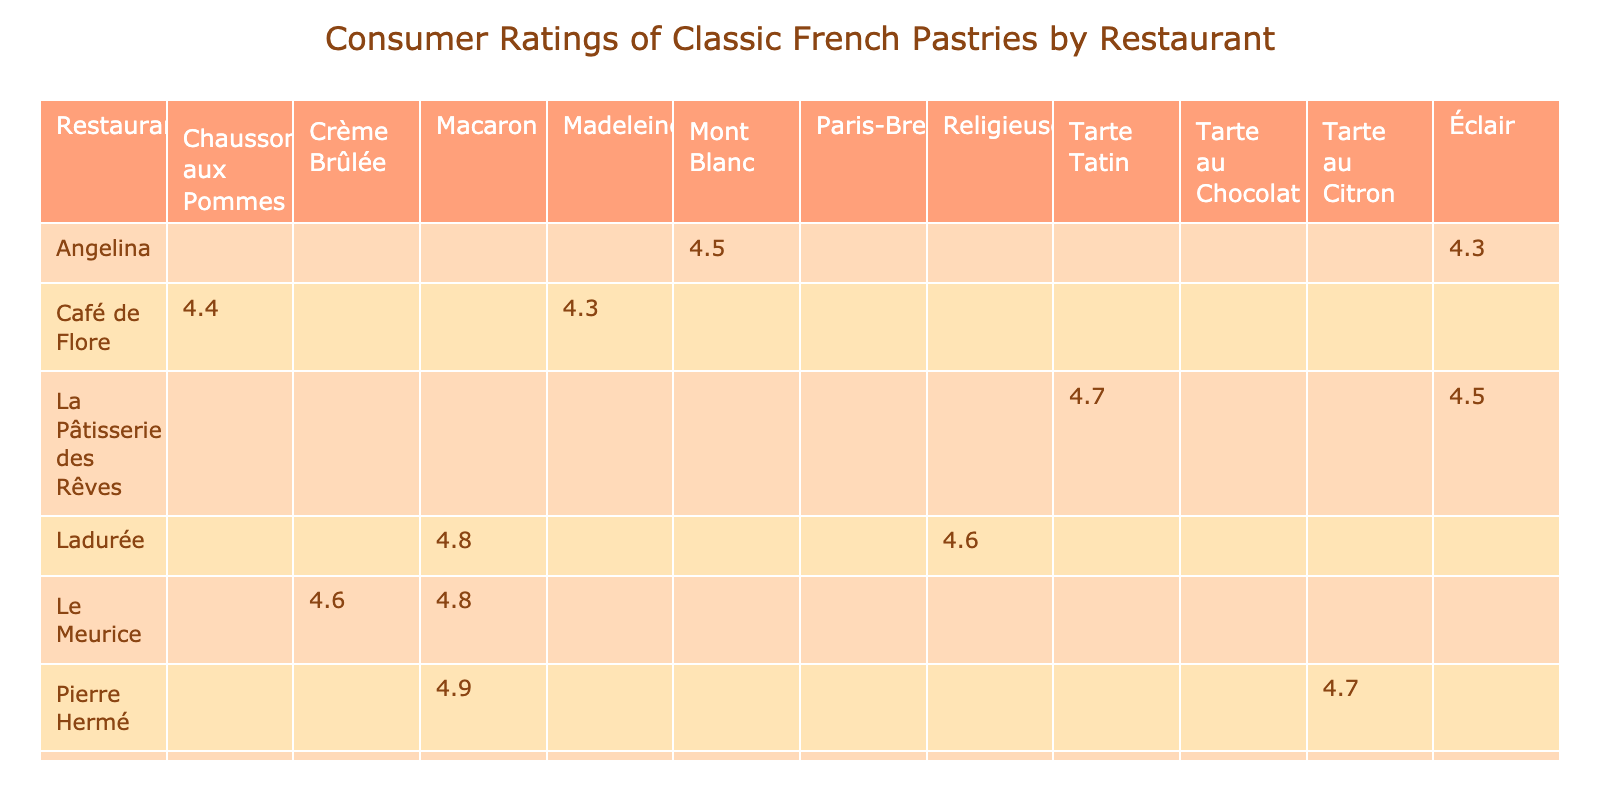What is the consumer rating of the Éclair at La Pâtisserie des Rêves? The table lists the consumer rating of the Éclair under La Pâtisserie des Rêves, which is stated as 4.5.
Answer: 4.5 Which pastry has the highest rating and at which restaurant? By examining the ratings, the Macaron at Pierre Hermé has the highest rating, listed as 4.9.
Answer: Macaron at Pierre Hermé Is the rating of the Chausson aux Pommes higher than that of the Madeleine? The rating for the Chausson aux Pommes is 4.4 and for the Madeleine is 4.3. Since 4.4 is higher than 4.3, the statement is true.
Answer: Yes What is the average consumer rating of the pastries offered by Le Meurice? The pastries from Le Meurice are rated 4.8 for the Macaron and 4.6 for the Crème Brûlée. Adding these ratings gives 4.8 + 4.6 = 9.4. Dividing by 2 gives an average of 9.4 / 2 = 4.7.
Answer: 4.7 Which restaurant has the lowest average consumer rating for its pastries? First, we summarize the ratings for each restaurant: Café de Flore has (4.4 + 4.3) / 2 = 4.35, La Pâtisserie des Rêves has (4.5 + 4.7) / 2 = 4.6, and so on. Calculating for all shows Café de Flore has the lowest average rating of 4.35.
Answer: Café de Flore Are there any restaurants serving Macarons that have a rating lower than 4.5? The table shows Ladurée has a Macaron rated at 4.8 and Pierre Hermé has one rated 4.9. Therefore, both are above 4.5, making the answer no.
Answer: No What is the sum of the ratings for the pastries offered by Pâtisserie Sébastien? The ratings at Pâtisserie Sébastien are 4.7 for the Paris-Brest and 4.5 for the Tarte au Chocolat. Adding these ratings gives 4.7 + 4.5 = 9.2.
Answer: 9.2 Is it true that all pastries from Pierre Hermé have a rating of 4.7 or higher? Pierre Hermé has a Macaron rated at 4.9 and a Tarte au Citron rated at 4.7, which means both pastries have ratings equal to or above 4.7, confirming the statement is true.
Answer: Yes Which pastry has a rating of 4.3 and from which restaurant is it? The table indicates that the Éclair from Angelina has the rating of 4.3.
Answer: Éclair from Angelina 